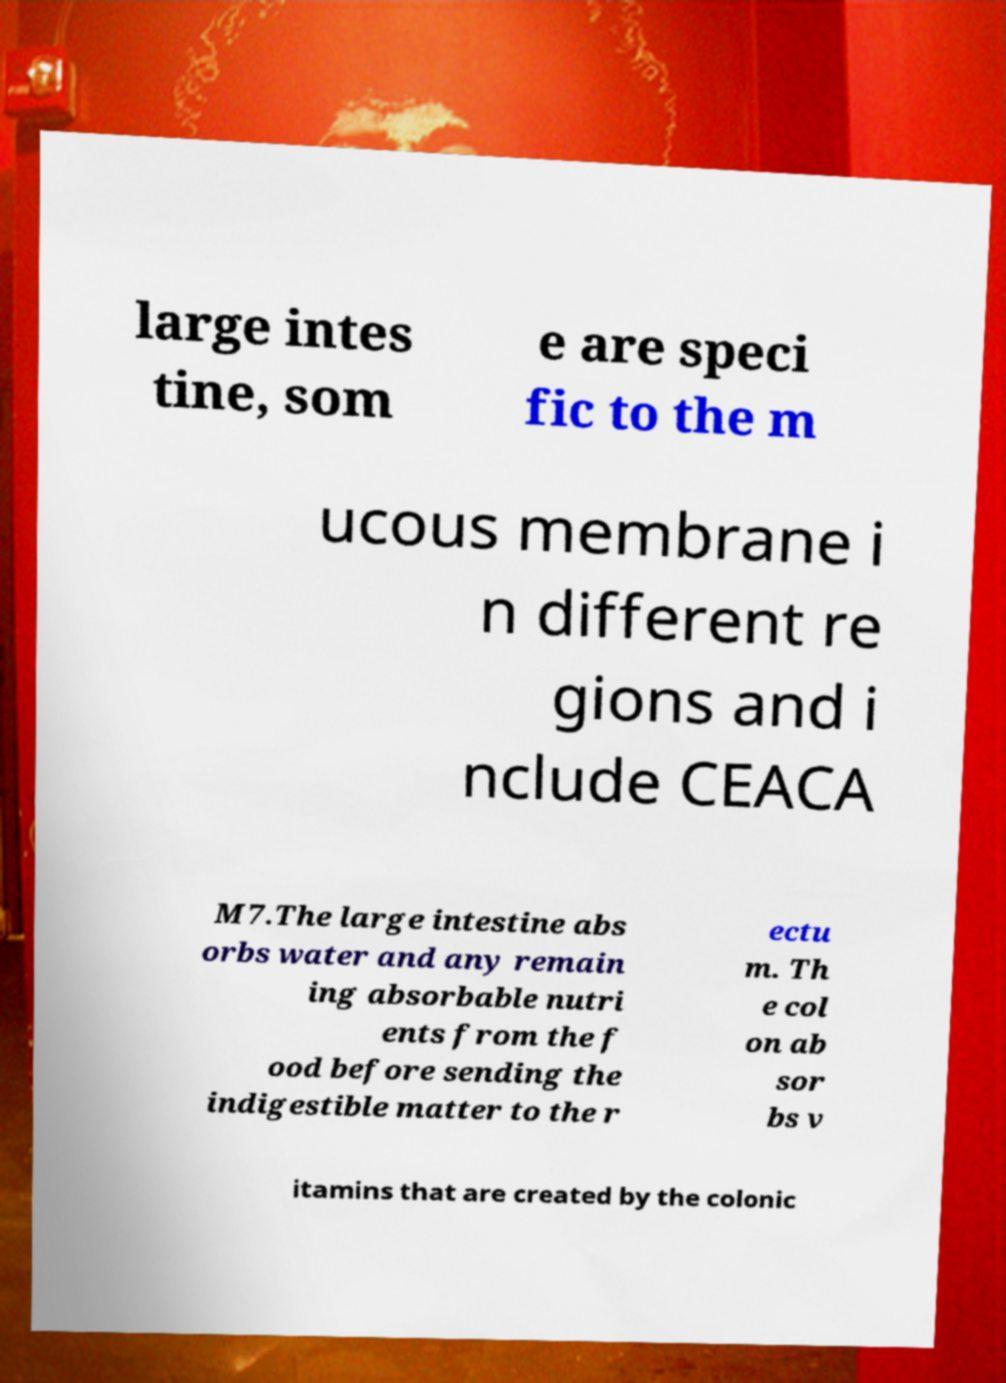Can you read and provide the text displayed in the image?This photo seems to have some interesting text. Can you extract and type it out for me? large intes tine, som e are speci fic to the m ucous membrane i n different re gions and i nclude CEACA M7.The large intestine abs orbs water and any remain ing absorbable nutri ents from the f ood before sending the indigestible matter to the r ectu m. Th e col on ab sor bs v itamins that are created by the colonic 